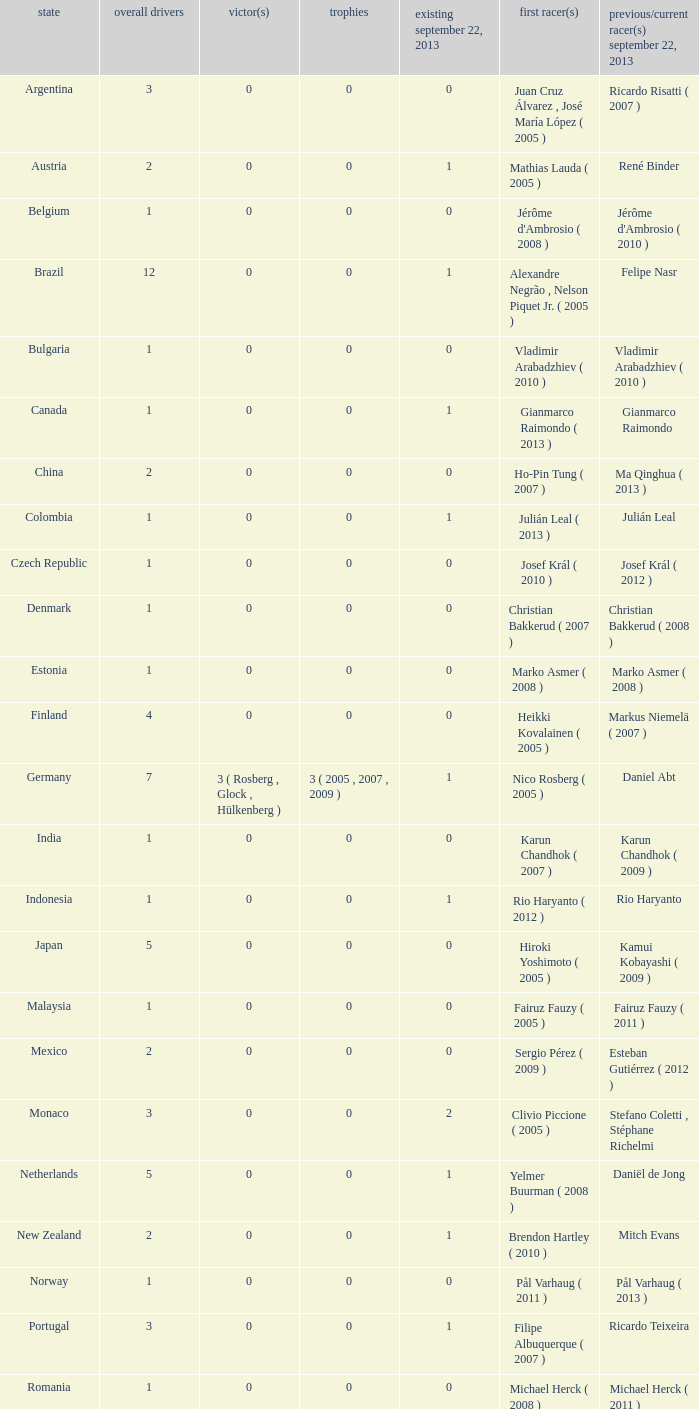How many entries are there for total drivers when the Last driver for september 22, 2013 was gianmarco raimondo? 1.0. 